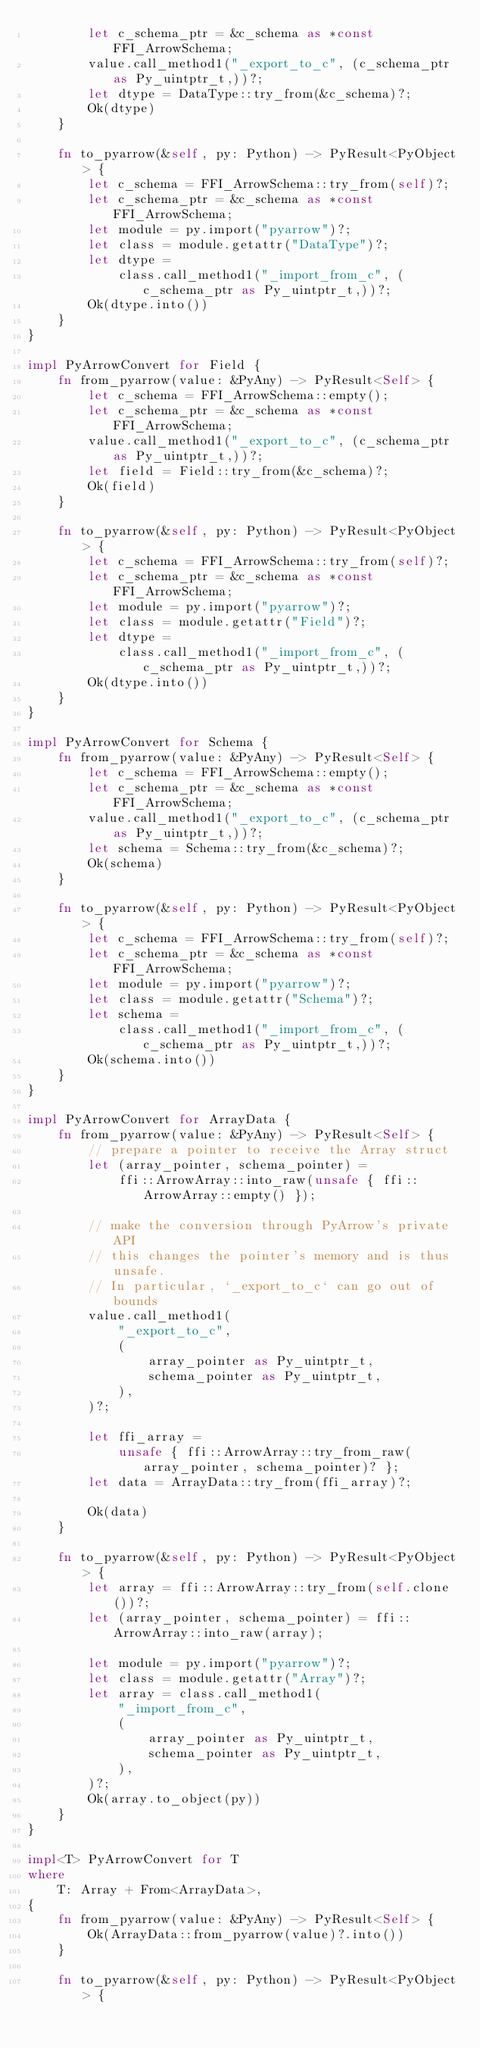Convert code to text. <code><loc_0><loc_0><loc_500><loc_500><_Rust_>        let c_schema_ptr = &c_schema as *const FFI_ArrowSchema;
        value.call_method1("_export_to_c", (c_schema_ptr as Py_uintptr_t,))?;
        let dtype = DataType::try_from(&c_schema)?;
        Ok(dtype)
    }

    fn to_pyarrow(&self, py: Python) -> PyResult<PyObject> {
        let c_schema = FFI_ArrowSchema::try_from(self)?;
        let c_schema_ptr = &c_schema as *const FFI_ArrowSchema;
        let module = py.import("pyarrow")?;
        let class = module.getattr("DataType")?;
        let dtype =
            class.call_method1("_import_from_c", (c_schema_ptr as Py_uintptr_t,))?;
        Ok(dtype.into())
    }
}

impl PyArrowConvert for Field {
    fn from_pyarrow(value: &PyAny) -> PyResult<Self> {
        let c_schema = FFI_ArrowSchema::empty();
        let c_schema_ptr = &c_schema as *const FFI_ArrowSchema;
        value.call_method1("_export_to_c", (c_schema_ptr as Py_uintptr_t,))?;
        let field = Field::try_from(&c_schema)?;
        Ok(field)
    }

    fn to_pyarrow(&self, py: Python) -> PyResult<PyObject> {
        let c_schema = FFI_ArrowSchema::try_from(self)?;
        let c_schema_ptr = &c_schema as *const FFI_ArrowSchema;
        let module = py.import("pyarrow")?;
        let class = module.getattr("Field")?;
        let dtype =
            class.call_method1("_import_from_c", (c_schema_ptr as Py_uintptr_t,))?;
        Ok(dtype.into())
    }
}

impl PyArrowConvert for Schema {
    fn from_pyarrow(value: &PyAny) -> PyResult<Self> {
        let c_schema = FFI_ArrowSchema::empty();
        let c_schema_ptr = &c_schema as *const FFI_ArrowSchema;
        value.call_method1("_export_to_c", (c_schema_ptr as Py_uintptr_t,))?;
        let schema = Schema::try_from(&c_schema)?;
        Ok(schema)
    }

    fn to_pyarrow(&self, py: Python) -> PyResult<PyObject> {
        let c_schema = FFI_ArrowSchema::try_from(self)?;
        let c_schema_ptr = &c_schema as *const FFI_ArrowSchema;
        let module = py.import("pyarrow")?;
        let class = module.getattr("Schema")?;
        let schema =
            class.call_method1("_import_from_c", (c_schema_ptr as Py_uintptr_t,))?;
        Ok(schema.into())
    }
}

impl PyArrowConvert for ArrayData {
    fn from_pyarrow(value: &PyAny) -> PyResult<Self> {
        // prepare a pointer to receive the Array struct
        let (array_pointer, schema_pointer) =
            ffi::ArrowArray::into_raw(unsafe { ffi::ArrowArray::empty() });

        // make the conversion through PyArrow's private API
        // this changes the pointer's memory and is thus unsafe.
        // In particular, `_export_to_c` can go out of bounds
        value.call_method1(
            "_export_to_c",
            (
                array_pointer as Py_uintptr_t,
                schema_pointer as Py_uintptr_t,
            ),
        )?;

        let ffi_array =
            unsafe { ffi::ArrowArray::try_from_raw(array_pointer, schema_pointer)? };
        let data = ArrayData::try_from(ffi_array)?;

        Ok(data)
    }

    fn to_pyarrow(&self, py: Python) -> PyResult<PyObject> {
        let array = ffi::ArrowArray::try_from(self.clone())?;
        let (array_pointer, schema_pointer) = ffi::ArrowArray::into_raw(array);

        let module = py.import("pyarrow")?;
        let class = module.getattr("Array")?;
        let array = class.call_method1(
            "_import_from_c",
            (
                array_pointer as Py_uintptr_t,
                schema_pointer as Py_uintptr_t,
            ),
        )?;
        Ok(array.to_object(py))
    }
}

impl<T> PyArrowConvert for T
where
    T: Array + From<ArrayData>,
{
    fn from_pyarrow(value: &PyAny) -> PyResult<Self> {
        Ok(ArrayData::from_pyarrow(value)?.into())
    }

    fn to_pyarrow(&self, py: Python) -> PyResult<PyObject> {</code> 